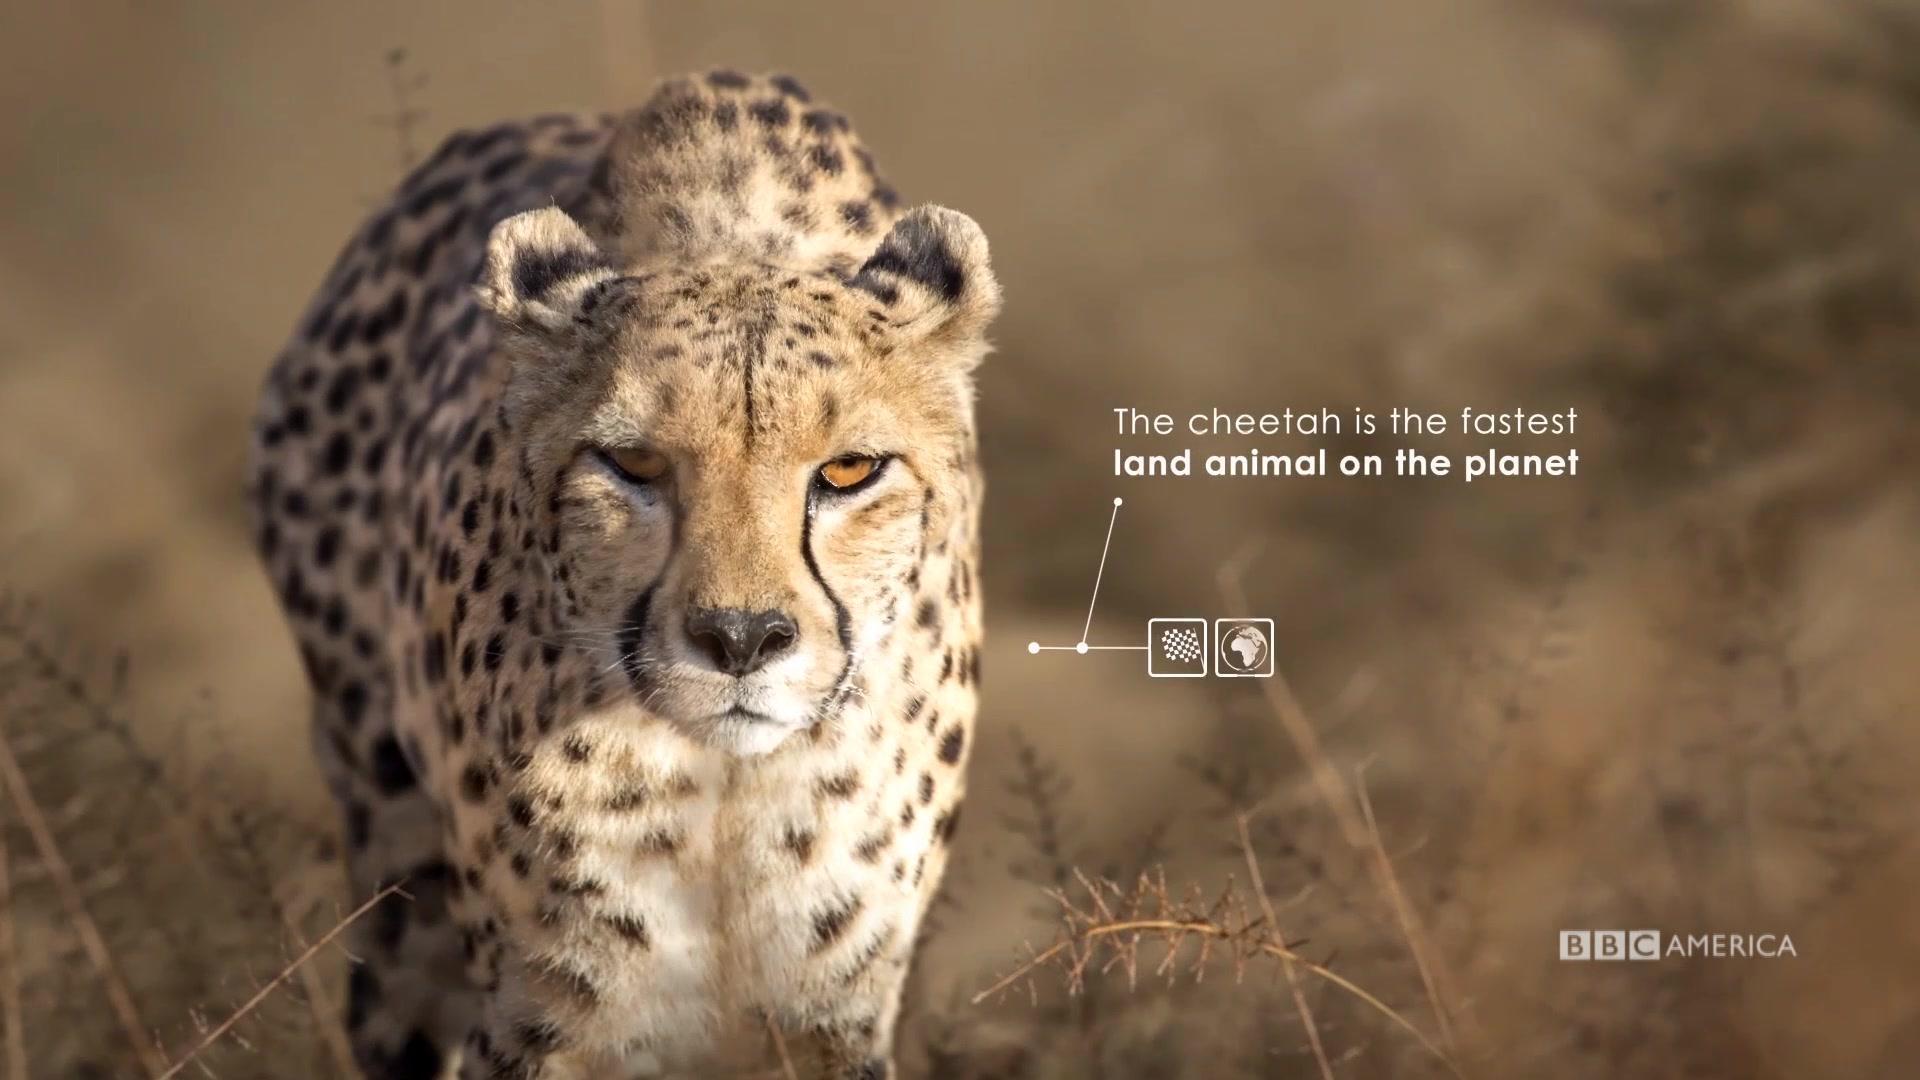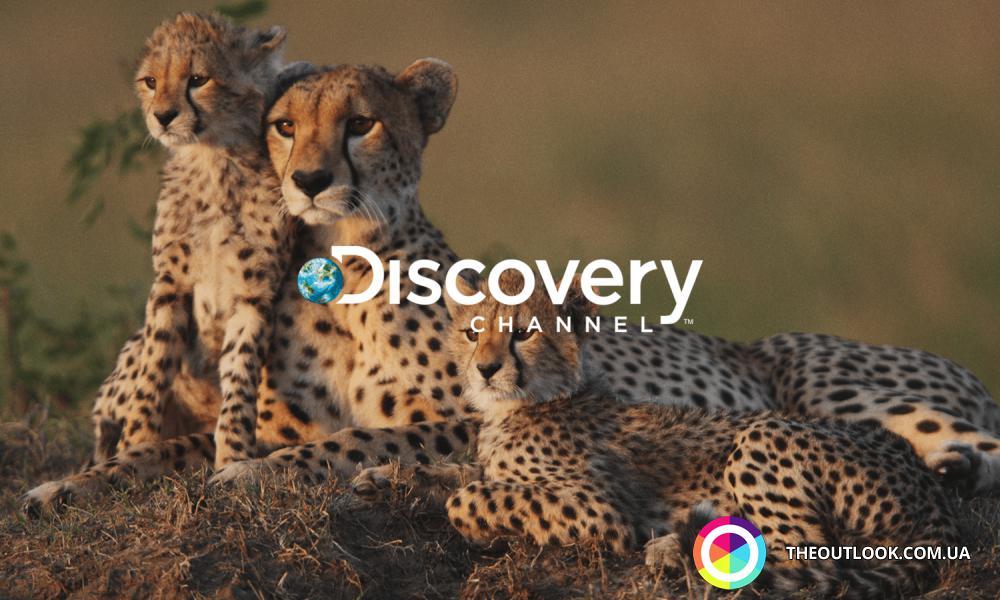The first image is the image on the left, the second image is the image on the right. Evaluate the accuracy of this statement regarding the images: "Each image contains exactly two cheetahs, and each image includes at least one reclining cheetah.". Is it true? Answer yes or no. No. The first image is the image on the left, the second image is the image on the right. Analyze the images presented: Is the assertion "In one of the images there is a single animal standing in a field." valid? Answer yes or no. Yes. 